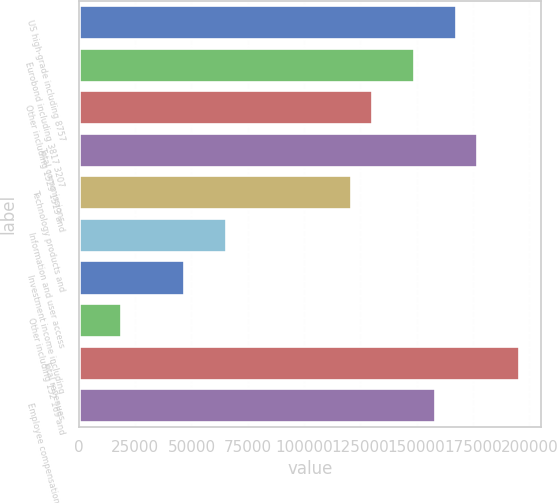<chart> <loc_0><loc_0><loc_500><loc_500><bar_chart><fcel>US high-grade including 8757<fcel>Eurobond including 3817 3207<fcel>Other including 1529 1513 and<fcel>Total commissions<fcel>Technology products and<fcel>Information and user access<fcel>Investment income including<fcel>Other including 152 169 and<fcel>Total revenues<fcel>Employee compensation and<nl><fcel>167553<fcel>148936<fcel>130319<fcel>176861<fcel>121010<fcel>65159.6<fcel>46542.6<fcel>18617.2<fcel>195478<fcel>158244<nl></chart> 